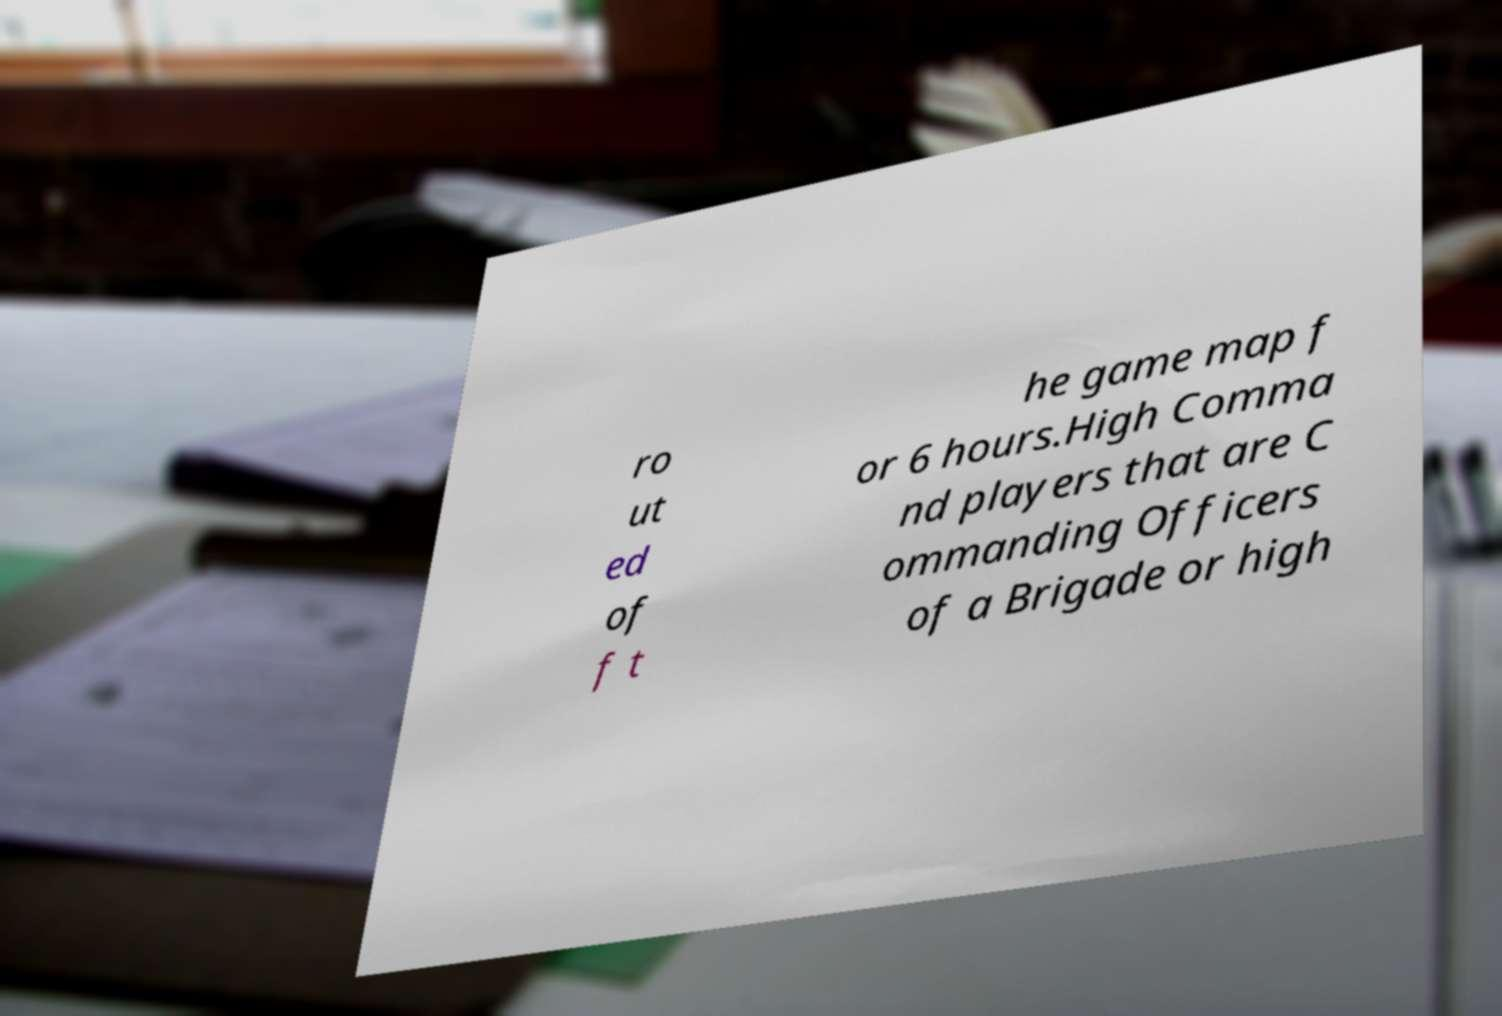Please identify and transcribe the text found in this image. ro ut ed of f t he game map f or 6 hours.High Comma nd players that are C ommanding Officers of a Brigade or high 